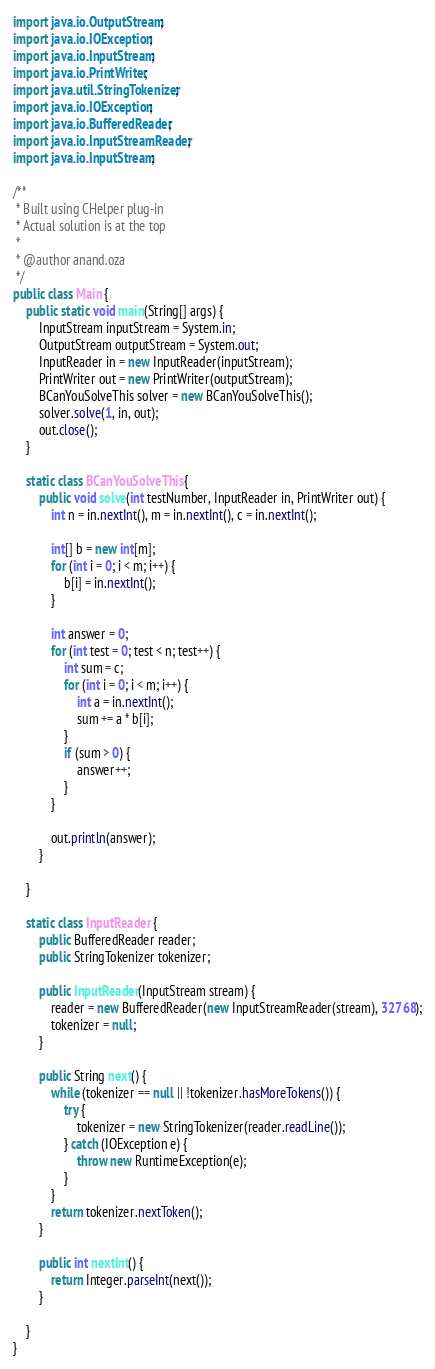Convert code to text. <code><loc_0><loc_0><loc_500><loc_500><_Java_>import java.io.OutputStream;
import java.io.IOException;
import java.io.InputStream;
import java.io.PrintWriter;
import java.util.StringTokenizer;
import java.io.IOException;
import java.io.BufferedReader;
import java.io.InputStreamReader;
import java.io.InputStream;

/**
 * Built using CHelper plug-in
 * Actual solution is at the top
 *
 * @author anand.oza
 */
public class Main {
    public static void main(String[] args) {
        InputStream inputStream = System.in;
        OutputStream outputStream = System.out;
        InputReader in = new InputReader(inputStream);
        PrintWriter out = new PrintWriter(outputStream);
        BCanYouSolveThis solver = new BCanYouSolveThis();
        solver.solve(1, in, out);
        out.close();
    }

    static class BCanYouSolveThis {
        public void solve(int testNumber, InputReader in, PrintWriter out) {
            int n = in.nextInt(), m = in.nextInt(), c = in.nextInt();

            int[] b = new int[m];
            for (int i = 0; i < m; i++) {
                b[i] = in.nextInt();
            }

            int answer = 0;
            for (int test = 0; test < n; test++) {
                int sum = c;
                for (int i = 0; i < m; i++) {
                    int a = in.nextInt();
                    sum += a * b[i];
                }
                if (sum > 0) {
                    answer++;
                }
            }

            out.println(answer);
        }

    }

    static class InputReader {
        public BufferedReader reader;
        public StringTokenizer tokenizer;

        public InputReader(InputStream stream) {
            reader = new BufferedReader(new InputStreamReader(stream), 32768);
            tokenizer = null;
        }

        public String next() {
            while (tokenizer == null || !tokenizer.hasMoreTokens()) {
                try {
                    tokenizer = new StringTokenizer(reader.readLine());
                } catch (IOException e) {
                    throw new RuntimeException(e);
                }
            }
            return tokenizer.nextToken();
        }

        public int nextInt() {
            return Integer.parseInt(next());
        }

    }
}

</code> 